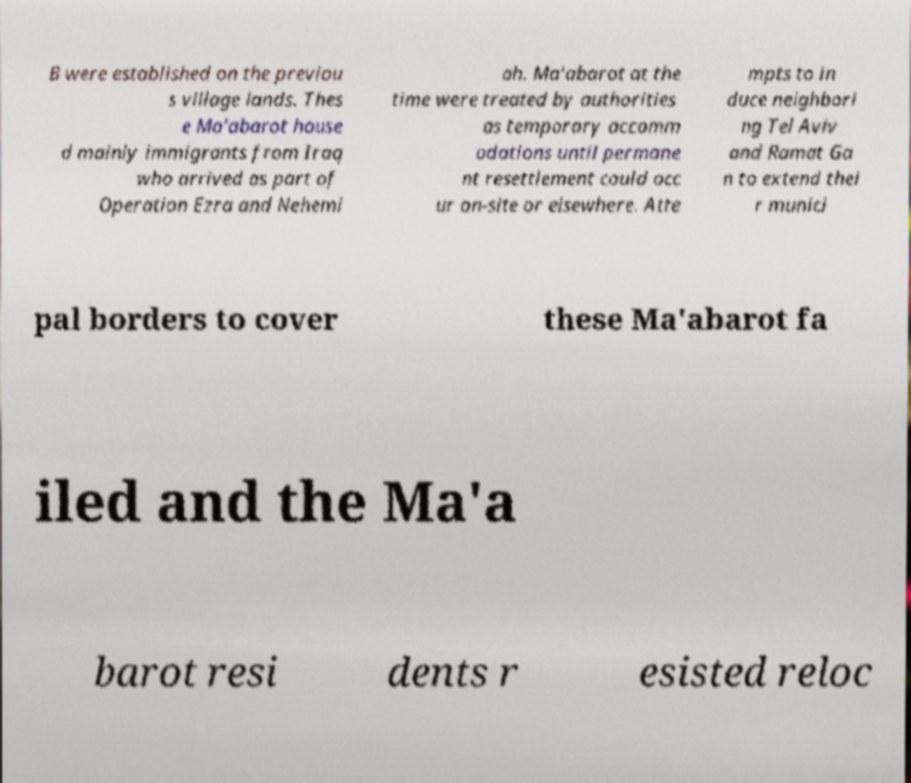Please identify and transcribe the text found in this image. B were established on the previou s village lands. Thes e Ma'abarot house d mainly immigrants from Iraq who arrived as part of Operation Ezra and Nehemi ah. Ma'abarot at the time were treated by authorities as temporary accomm odations until permane nt resettlement could occ ur on-site or elsewhere. Atte mpts to in duce neighbori ng Tel Aviv and Ramat Ga n to extend thei r munici pal borders to cover these Ma'abarot fa iled and the Ma'a barot resi dents r esisted reloc 